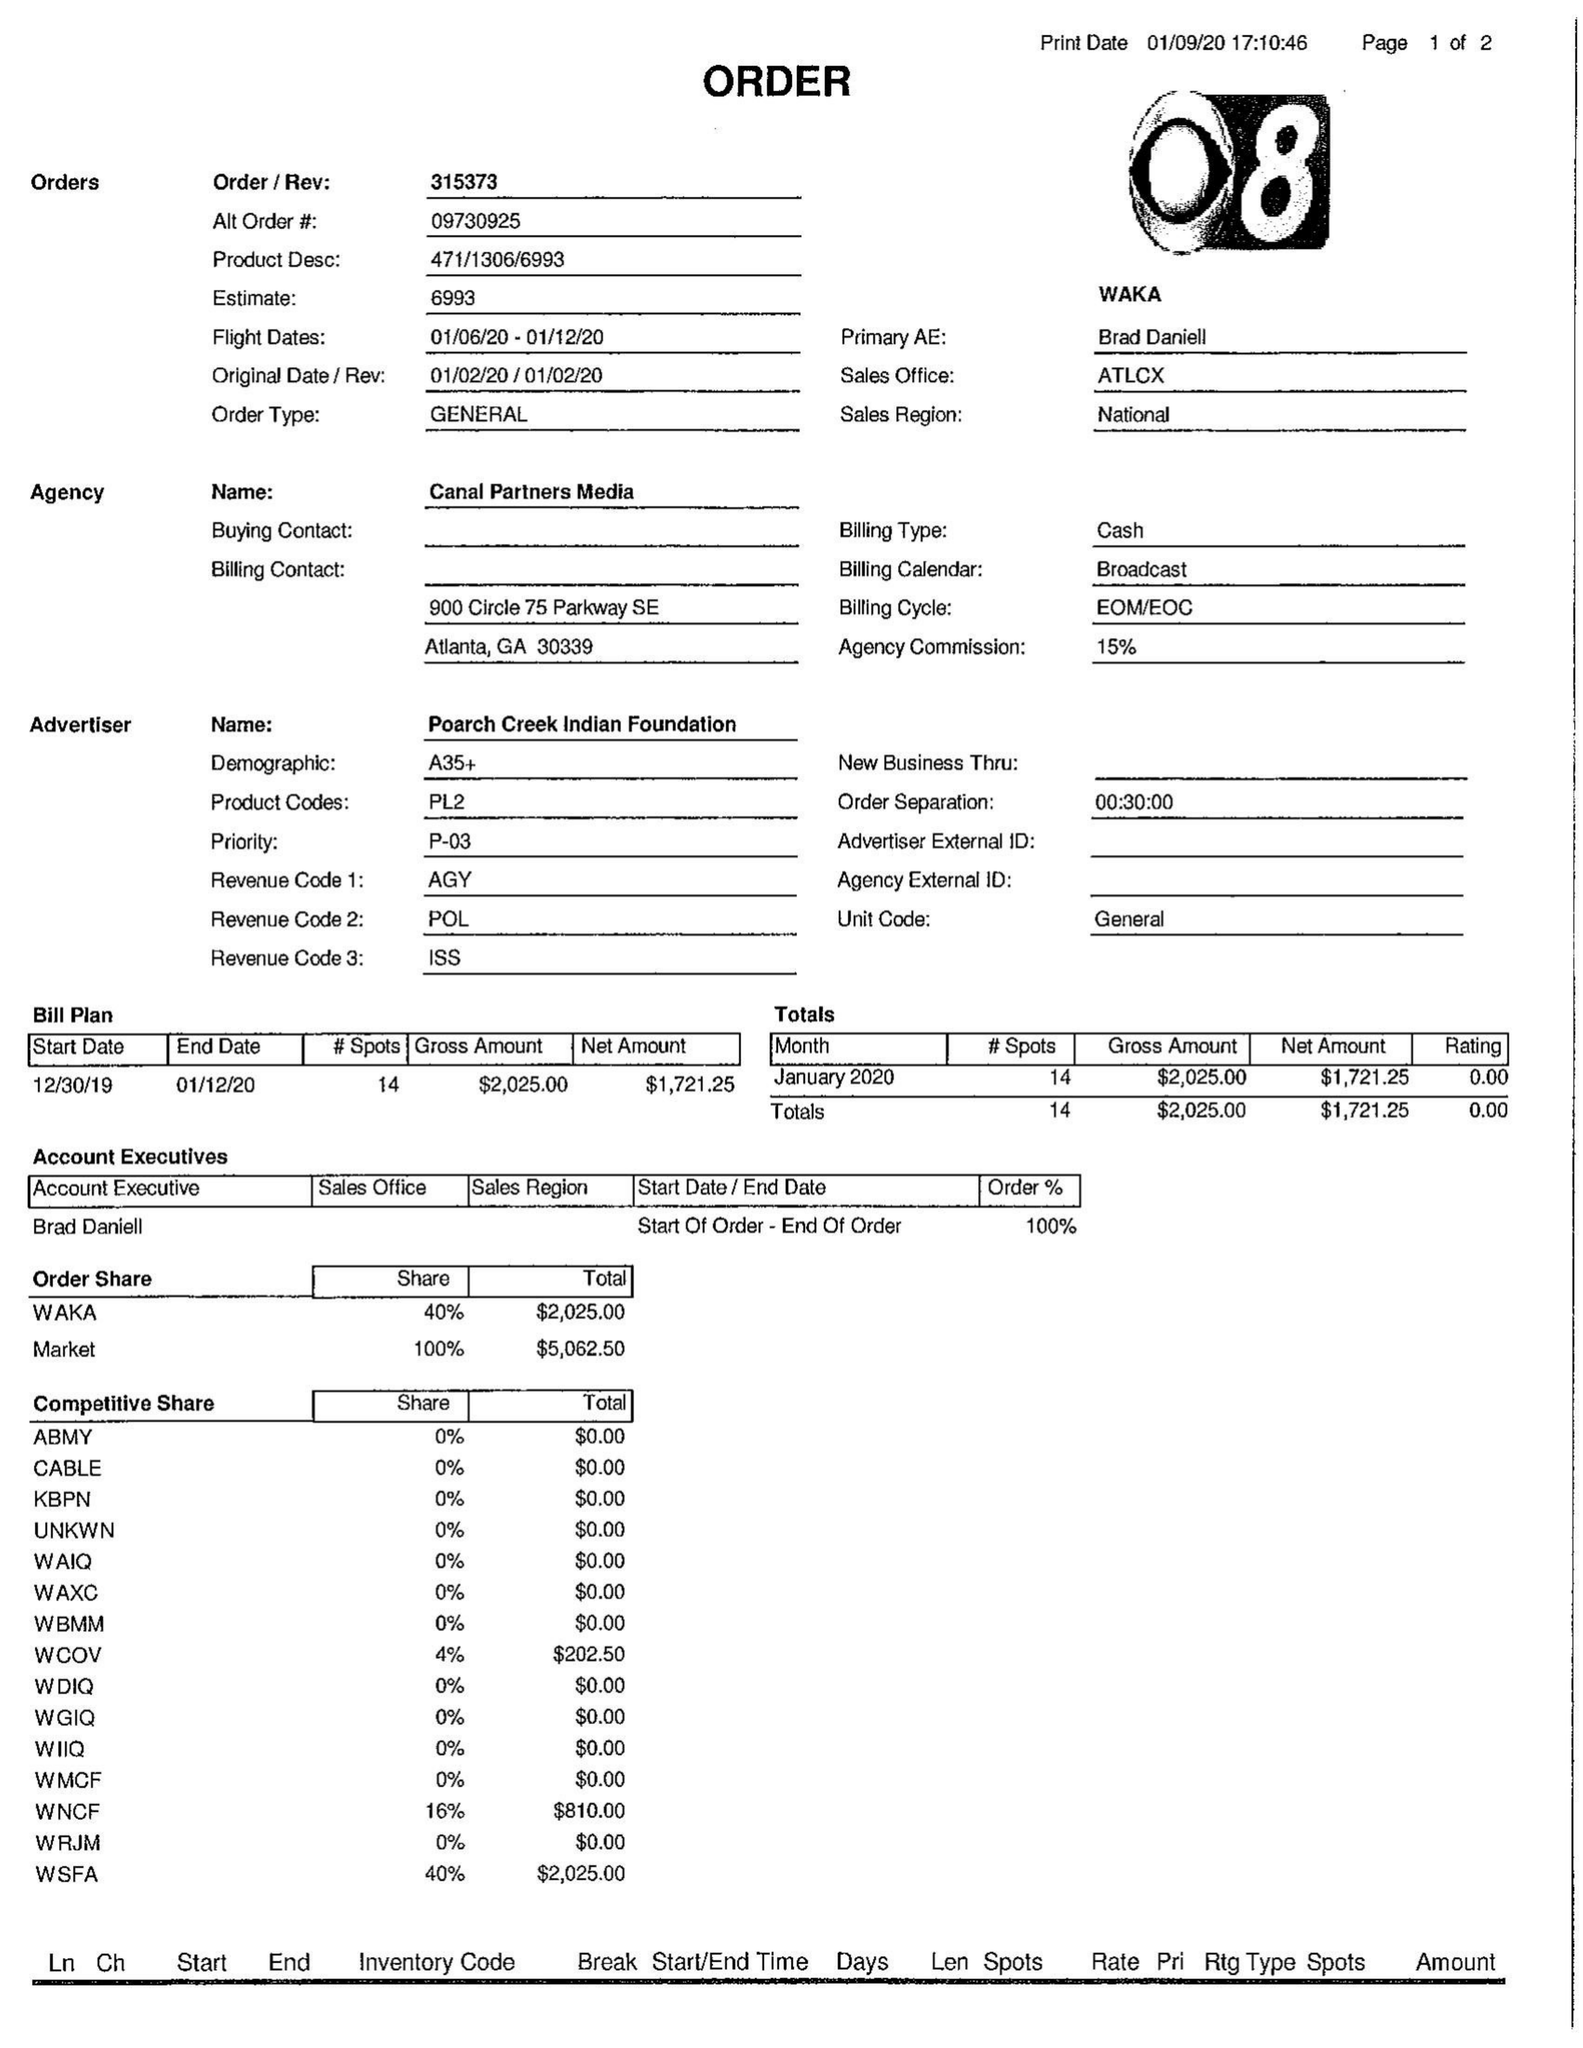What is the value for the advertiser?
Answer the question using a single word or phrase. CANAL PARTNERS MEDIA 